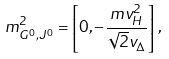Convert formula to latex. <formula><loc_0><loc_0><loc_500><loc_500>m _ { G ^ { 0 } , J ^ { 0 } } ^ { 2 } = \left [ 0 , - \frac { m v _ { H } ^ { 2 } } { \sqrt { 2 } v _ { \Delta } } \right ] \, ,</formula> 